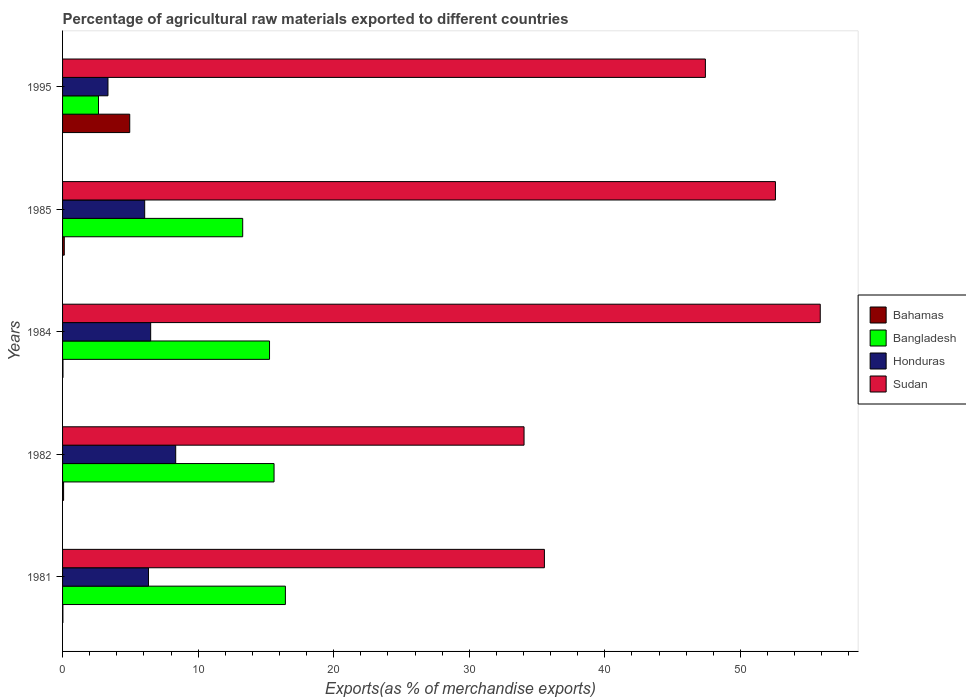How many different coloured bars are there?
Your response must be concise. 4. Are the number of bars on each tick of the Y-axis equal?
Give a very brief answer. Yes. How many bars are there on the 2nd tick from the top?
Keep it short and to the point. 4. In how many cases, is the number of bars for a given year not equal to the number of legend labels?
Keep it short and to the point. 0. What is the percentage of exports to different countries in Sudan in 1981?
Offer a very short reply. 35.54. Across all years, what is the maximum percentage of exports to different countries in Bangladesh?
Your answer should be very brief. 16.44. Across all years, what is the minimum percentage of exports to different countries in Bangladesh?
Your response must be concise. 2.65. In which year was the percentage of exports to different countries in Sudan maximum?
Your answer should be very brief. 1984. What is the total percentage of exports to different countries in Sudan in the graph?
Ensure brevity in your answer.  225.48. What is the difference between the percentage of exports to different countries in Bangladesh in 1981 and that in 1984?
Give a very brief answer. 1.17. What is the difference between the percentage of exports to different countries in Honduras in 1981 and the percentage of exports to different countries in Sudan in 1985?
Make the answer very short. -46.25. What is the average percentage of exports to different countries in Bangladesh per year?
Your response must be concise. 12.65. In the year 1984, what is the difference between the percentage of exports to different countries in Bahamas and percentage of exports to different countries in Bangladesh?
Provide a succinct answer. -15.24. What is the ratio of the percentage of exports to different countries in Bangladesh in 1981 to that in 1984?
Your answer should be compact. 1.08. Is the percentage of exports to different countries in Bangladesh in 1985 less than that in 1995?
Your answer should be very brief. No. Is the difference between the percentage of exports to different countries in Bahamas in 1981 and 1985 greater than the difference between the percentage of exports to different countries in Bangladesh in 1981 and 1985?
Keep it short and to the point. No. What is the difference between the highest and the second highest percentage of exports to different countries in Honduras?
Your answer should be very brief. 1.85. What is the difference between the highest and the lowest percentage of exports to different countries in Bahamas?
Give a very brief answer. 4.93. In how many years, is the percentage of exports to different countries in Honduras greater than the average percentage of exports to different countries in Honduras taken over all years?
Your answer should be very brief. 3. What does the 4th bar from the top in 1985 represents?
Your answer should be very brief. Bahamas. What does the 1st bar from the bottom in 1985 represents?
Give a very brief answer. Bahamas. Is it the case that in every year, the sum of the percentage of exports to different countries in Honduras and percentage of exports to different countries in Sudan is greater than the percentage of exports to different countries in Bangladesh?
Your response must be concise. Yes. Are all the bars in the graph horizontal?
Offer a terse response. Yes. How many years are there in the graph?
Offer a very short reply. 5. What is the difference between two consecutive major ticks on the X-axis?
Keep it short and to the point. 10. What is the title of the graph?
Make the answer very short. Percentage of agricultural raw materials exported to different countries. Does "Fragile and conflict affected situations" appear as one of the legend labels in the graph?
Ensure brevity in your answer.  No. What is the label or title of the X-axis?
Your response must be concise. Exports(as % of merchandise exports). What is the label or title of the Y-axis?
Your response must be concise. Years. What is the Exports(as % of merchandise exports) in Bahamas in 1981?
Your answer should be very brief. 0.02. What is the Exports(as % of merchandise exports) in Bangladesh in 1981?
Offer a terse response. 16.44. What is the Exports(as % of merchandise exports) of Honduras in 1981?
Offer a very short reply. 6.34. What is the Exports(as % of merchandise exports) of Sudan in 1981?
Your answer should be very brief. 35.54. What is the Exports(as % of merchandise exports) of Bahamas in 1982?
Offer a terse response. 0.08. What is the Exports(as % of merchandise exports) in Bangladesh in 1982?
Give a very brief answer. 15.6. What is the Exports(as % of merchandise exports) in Honduras in 1982?
Make the answer very short. 8.35. What is the Exports(as % of merchandise exports) of Sudan in 1982?
Make the answer very short. 34.04. What is the Exports(as % of merchandise exports) in Bahamas in 1984?
Give a very brief answer. 0.03. What is the Exports(as % of merchandise exports) of Bangladesh in 1984?
Offer a very short reply. 15.27. What is the Exports(as % of merchandise exports) of Honduras in 1984?
Make the answer very short. 6.5. What is the Exports(as % of merchandise exports) of Sudan in 1984?
Make the answer very short. 55.89. What is the Exports(as % of merchandise exports) of Bahamas in 1985?
Ensure brevity in your answer.  0.13. What is the Exports(as % of merchandise exports) in Bangladesh in 1985?
Offer a terse response. 13.29. What is the Exports(as % of merchandise exports) of Honduras in 1985?
Ensure brevity in your answer.  6.06. What is the Exports(as % of merchandise exports) in Sudan in 1985?
Make the answer very short. 52.59. What is the Exports(as % of merchandise exports) in Bahamas in 1995?
Your answer should be very brief. 4.95. What is the Exports(as % of merchandise exports) in Bangladesh in 1995?
Keep it short and to the point. 2.65. What is the Exports(as % of merchandise exports) in Honduras in 1995?
Provide a short and direct response. 3.35. What is the Exports(as % of merchandise exports) of Sudan in 1995?
Ensure brevity in your answer.  47.42. Across all years, what is the maximum Exports(as % of merchandise exports) in Bahamas?
Your answer should be very brief. 4.95. Across all years, what is the maximum Exports(as % of merchandise exports) in Bangladesh?
Offer a very short reply. 16.44. Across all years, what is the maximum Exports(as % of merchandise exports) in Honduras?
Provide a short and direct response. 8.35. Across all years, what is the maximum Exports(as % of merchandise exports) of Sudan?
Your answer should be compact. 55.89. Across all years, what is the minimum Exports(as % of merchandise exports) of Bahamas?
Offer a terse response. 0.02. Across all years, what is the minimum Exports(as % of merchandise exports) in Bangladesh?
Keep it short and to the point. 2.65. Across all years, what is the minimum Exports(as % of merchandise exports) of Honduras?
Your answer should be compact. 3.35. Across all years, what is the minimum Exports(as % of merchandise exports) of Sudan?
Provide a succinct answer. 34.04. What is the total Exports(as % of merchandise exports) of Bahamas in the graph?
Your answer should be very brief. 5.21. What is the total Exports(as % of merchandise exports) of Bangladesh in the graph?
Provide a succinct answer. 63.24. What is the total Exports(as % of merchandise exports) in Honduras in the graph?
Keep it short and to the point. 30.59. What is the total Exports(as % of merchandise exports) of Sudan in the graph?
Your response must be concise. 225.48. What is the difference between the Exports(as % of merchandise exports) in Bahamas in 1981 and that in 1982?
Your answer should be very brief. -0.05. What is the difference between the Exports(as % of merchandise exports) in Bangladesh in 1981 and that in 1982?
Your response must be concise. 0.84. What is the difference between the Exports(as % of merchandise exports) of Honduras in 1981 and that in 1982?
Offer a terse response. -2.01. What is the difference between the Exports(as % of merchandise exports) of Sudan in 1981 and that in 1982?
Offer a terse response. 1.5. What is the difference between the Exports(as % of merchandise exports) of Bahamas in 1981 and that in 1984?
Give a very brief answer. -0.01. What is the difference between the Exports(as % of merchandise exports) in Bangladesh in 1981 and that in 1984?
Your answer should be very brief. 1.17. What is the difference between the Exports(as % of merchandise exports) of Honduras in 1981 and that in 1984?
Your response must be concise. -0.16. What is the difference between the Exports(as % of merchandise exports) in Sudan in 1981 and that in 1984?
Your answer should be very brief. -20.35. What is the difference between the Exports(as % of merchandise exports) in Bahamas in 1981 and that in 1985?
Your answer should be compact. -0.1. What is the difference between the Exports(as % of merchandise exports) in Bangladesh in 1981 and that in 1985?
Ensure brevity in your answer.  3.15. What is the difference between the Exports(as % of merchandise exports) in Honduras in 1981 and that in 1985?
Your answer should be compact. 0.28. What is the difference between the Exports(as % of merchandise exports) of Sudan in 1981 and that in 1985?
Your answer should be compact. -17.04. What is the difference between the Exports(as % of merchandise exports) of Bahamas in 1981 and that in 1995?
Keep it short and to the point. -4.93. What is the difference between the Exports(as % of merchandise exports) of Bangladesh in 1981 and that in 1995?
Ensure brevity in your answer.  13.79. What is the difference between the Exports(as % of merchandise exports) of Honduras in 1981 and that in 1995?
Your answer should be compact. 2.99. What is the difference between the Exports(as % of merchandise exports) in Sudan in 1981 and that in 1995?
Ensure brevity in your answer.  -11.88. What is the difference between the Exports(as % of merchandise exports) in Bahamas in 1982 and that in 1984?
Ensure brevity in your answer.  0.05. What is the difference between the Exports(as % of merchandise exports) in Bangladesh in 1982 and that in 1984?
Your answer should be very brief. 0.33. What is the difference between the Exports(as % of merchandise exports) in Honduras in 1982 and that in 1984?
Make the answer very short. 1.85. What is the difference between the Exports(as % of merchandise exports) in Sudan in 1982 and that in 1984?
Give a very brief answer. -21.85. What is the difference between the Exports(as % of merchandise exports) of Bahamas in 1982 and that in 1985?
Keep it short and to the point. -0.05. What is the difference between the Exports(as % of merchandise exports) of Bangladesh in 1982 and that in 1985?
Offer a very short reply. 2.31. What is the difference between the Exports(as % of merchandise exports) of Honduras in 1982 and that in 1985?
Make the answer very short. 2.29. What is the difference between the Exports(as % of merchandise exports) in Sudan in 1982 and that in 1985?
Make the answer very short. -18.54. What is the difference between the Exports(as % of merchandise exports) of Bahamas in 1982 and that in 1995?
Give a very brief answer. -4.88. What is the difference between the Exports(as % of merchandise exports) in Bangladesh in 1982 and that in 1995?
Keep it short and to the point. 12.95. What is the difference between the Exports(as % of merchandise exports) in Honduras in 1982 and that in 1995?
Offer a terse response. 5. What is the difference between the Exports(as % of merchandise exports) in Sudan in 1982 and that in 1995?
Ensure brevity in your answer.  -13.38. What is the difference between the Exports(as % of merchandise exports) of Bahamas in 1984 and that in 1985?
Offer a terse response. -0.1. What is the difference between the Exports(as % of merchandise exports) of Bangladesh in 1984 and that in 1985?
Provide a short and direct response. 1.98. What is the difference between the Exports(as % of merchandise exports) in Honduras in 1984 and that in 1985?
Your answer should be very brief. 0.44. What is the difference between the Exports(as % of merchandise exports) of Sudan in 1984 and that in 1985?
Make the answer very short. 3.31. What is the difference between the Exports(as % of merchandise exports) of Bahamas in 1984 and that in 1995?
Give a very brief answer. -4.92. What is the difference between the Exports(as % of merchandise exports) of Bangladesh in 1984 and that in 1995?
Give a very brief answer. 12.62. What is the difference between the Exports(as % of merchandise exports) of Honduras in 1984 and that in 1995?
Provide a short and direct response. 3.15. What is the difference between the Exports(as % of merchandise exports) of Sudan in 1984 and that in 1995?
Give a very brief answer. 8.47. What is the difference between the Exports(as % of merchandise exports) in Bahamas in 1985 and that in 1995?
Your answer should be very brief. -4.83. What is the difference between the Exports(as % of merchandise exports) in Bangladesh in 1985 and that in 1995?
Your answer should be compact. 10.64. What is the difference between the Exports(as % of merchandise exports) of Honduras in 1985 and that in 1995?
Keep it short and to the point. 2.71. What is the difference between the Exports(as % of merchandise exports) of Sudan in 1985 and that in 1995?
Keep it short and to the point. 5.17. What is the difference between the Exports(as % of merchandise exports) of Bahamas in 1981 and the Exports(as % of merchandise exports) of Bangladesh in 1982?
Your answer should be compact. -15.58. What is the difference between the Exports(as % of merchandise exports) in Bahamas in 1981 and the Exports(as % of merchandise exports) in Honduras in 1982?
Offer a terse response. -8.32. What is the difference between the Exports(as % of merchandise exports) in Bahamas in 1981 and the Exports(as % of merchandise exports) in Sudan in 1982?
Offer a very short reply. -34.02. What is the difference between the Exports(as % of merchandise exports) of Bangladesh in 1981 and the Exports(as % of merchandise exports) of Honduras in 1982?
Provide a short and direct response. 8.09. What is the difference between the Exports(as % of merchandise exports) of Bangladesh in 1981 and the Exports(as % of merchandise exports) of Sudan in 1982?
Make the answer very short. -17.61. What is the difference between the Exports(as % of merchandise exports) in Honduras in 1981 and the Exports(as % of merchandise exports) in Sudan in 1982?
Provide a succinct answer. -27.7. What is the difference between the Exports(as % of merchandise exports) of Bahamas in 1981 and the Exports(as % of merchandise exports) of Bangladesh in 1984?
Offer a terse response. -15.24. What is the difference between the Exports(as % of merchandise exports) of Bahamas in 1981 and the Exports(as % of merchandise exports) of Honduras in 1984?
Your response must be concise. -6.48. What is the difference between the Exports(as % of merchandise exports) in Bahamas in 1981 and the Exports(as % of merchandise exports) in Sudan in 1984?
Keep it short and to the point. -55.87. What is the difference between the Exports(as % of merchandise exports) in Bangladesh in 1981 and the Exports(as % of merchandise exports) in Honduras in 1984?
Your answer should be very brief. 9.94. What is the difference between the Exports(as % of merchandise exports) in Bangladesh in 1981 and the Exports(as % of merchandise exports) in Sudan in 1984?
Give a very brief answer. -39.45. What is the difference between the Exports(as % of merchandise exports) in Honduras in 1981 and the Exports(as % of merchandise exports) in Sudan in 1984?
Make the answer very short. -49.55. What is the difference between the Exports(as % of merchandise exports) in Bahamas in 1981 and the Exports(as % of merchandise exports) in Bangladesh in 1985?
Give a very brief answer. -13.26. What is the difference between the Exports(as % of merchandise exports) in Bahamas in 1981 and the Exports(as % of merchandise exports) in Honduras in 1985?
Provide a short and direct response. -6.03. What is the difference between the Exports(as % of merchandise exports) in Bahamas in 1981 and the Exports(as % of merchandise exports) in Sudan in 1985?
Your answer should be very brief. -52.56. What is the difference between the Exports(as % of merchandise exports) in Bangladesh in 1981 and the Exports(as % of merchandise exports) in Honduras in 1985?
Make the answer very short. 10.38. What is the difference between the Exports(as % of merchandise exports) of Bangladesh in 1981 and the Exports(as % of merchandise exports) of Sudan in 1985?
Give a very brief answer. -36.15. What is the difference between the Exports(as % of merchandise exports) in Honduras in 1981 and the Exports(as % of merchandise exports) in Sudan in 1985?
Your answer should be very brief. -46.25. What is the difference between the Exports(as % of merchandise exports) of Bahamas in 1981 and the Exports(as % of merchandise exports) of Bangladesh in 1995?
Your answer should be compact. -2.63. What is the difference between the Exports(as % of merchandise exports) of Bahamas in 1981 and the Exports(as % of merchandise exports) of Honduras in 1995?
Offer a very short reply. -3.32. What is the difference between the Exports(as % of merchandise exports) in Bahamas in 1981 and the Exports(as % of merchandise exports) in Sudan in 1995?
Offer a terse response. -47.39. What is the difference between the Exports(as % of merchandise exports) of Bangladesh in 1981 and the Exports(as % of merchandise exports) of Honduras in 1995?
Offer a terse response. 13.09. What is the difference between the Exports(as % of merchandise exports) in Bangladesh in 1981 and the Exports(as % of merchandise exports) in Sudan in 1995?
Give a very brief answer. -30.98. What is the difference between the Exports(as % of merchandise exports) of Honduras in 1981 and the Exports(as % of merchandise exports) of Sudan in 1995?
Offer a terse response. -41.08. What is the difference between the Exports(as % of merchandise exports) of Bahamas in 1982 and the Exports(as % of merchandise exports) of Bangladesh in 1984?
Keep it short and to the point. -15.19. What is the difference between the Exports(as % of merchandise exports) in Bahamas in 1982 and the Exports(as % of merchandise exports) in Honduras in 1984?
Offer a terse response. -6.42. What is the difference between the Exports(as % of merchandise exports) in Bahamas in 1982 and the Exports(as % of merchandise exports) in Sudan in 1984?
Offer a terse response. -55.81. What is the difference between the Exports(as % of merchandise exports) of Bangladesh in 1982 and the Exports(as % of merchandise exports) of Honduras in 1984?
Offer a very short reply. 9.1. What is the difference between the Exports(as % of merchandise exports) of Bangladesh in 1982 and the Exports(as % of merchandise exports) of Sudan in 1984?
Offer a terse response. -40.29. What is the difference between the Exports(as % of merchandise exports) in Honduras in 1982 and the Exports(as % of merchandise exports) in Sudan in 1984?
Offer a very short reply. -47.54. What is the difference between the Exports(as % of merchandise exports) of Bahamas in 1982 and the Exports(as % of merchandise exports) of Bangladesh in 1985?
Offer a very short reply. -13.21. What is the difference between the Exports(as % of merchandise exports) of Bahamas in 1982 and the Exports(as % of merchandise exports) of Honduras in 1985?
Your response must be concise. -5.98. What is the difference between the Exports(as % of merchandise exports) of Bahamas in 1982 and the Exports(as % of merchandise exports) of Sudan in 1985?
Provide a short and direct response. -52.51. What is the difference between the Exports(as % of merchandise exports) in Bangladesh in 1982 and the Exports(as % of merchandise exports) in Honduras in 1985?
Provide a short and direct response. 9.54. What is the difference between the Exports(as % of merchandise exports) in Bangladesh in 1982 and the Exports(as % of merchandise exports) in Sudan in 1985?
Provide a succinct answer. -36.99. What is the difference between the Exports(as % of merchandise exports) of Honduras in 1982 and the Exports(as % of merchandise exports) of Sudan in 1985?
Make the answer very short. -44.24. What is the difference between the Exports(as % of merchandise exports) of Bahamas in 1982 and the Exports(as % of merchandise exports) of Bangladesh in 1995?
Keep it short and to the point. -2.57. What is the difference between the Exports(as % of merchandise exports) of Bahamas in 1982 and the Exports(as % of merchandise exports) of Honduras in 1995?
Keep it short and to the point. -3.27. What is the difference between the Exports(as % of merchandise exports) in Bahamas in 1982 and the Exports(as % of merchandise exports) in Sudan in 1995?
Ensure brevity in your answer.  -47.34. What is the difference between the Exports(as % of merchandise exports) of Bangladesh in 1982 and the Exports(as % of merchandise exports) of Honduras in 1995?
Your response must be concise. 12.25. What is the difference between the Exports(as % of merchandise exports) in Bangladesh in 1982 and the Exports(as % of merchandise exports) in Sudan in 1995?
Offer a terse response. -31.82. What is the difference between the Exports(as % of merchandise exports) in Honduras in 1982 and the Exports(as % of merchandise exports) in Sudan in 1995?
Provide a short and direct response. -39.07. What is the difference between the Exports(as % of merchandise exports) in Bahamas in 1984 and the Exports(as % of merchandise exports) in Bangladesh in 1985?
Provide a succinct answer. -13.26. What is the difference between the Exports(as % of merchandise exports) in Bahamas in 1984 and the Exports(as % of merchandise exports) in Honduras in 1985?
Your answer should be very brief. -6.03. What is the difference between the Exports(as % of merchandise exports) of Bahamas in 1984 and the Exports(as % of merchandise exports) of Sudan in 1985?
Your answer should be compact. -52.55. What is the difference between the Exports(as % of merchandise exports) in Bangladesh in 1984 and the Exports(as % of merchandise exports) in Honduras in 1985?
Provide a succinct answer. 9.21. What is the difference between the Exports(as % of merchandise exports) of Bangladesh in 1984 and the Exports(as % of merchandise exports) of Sudan in 1985?
Keep it short and to the point. -37.32. What is the difference between the Exports(as % of merchandise exports) in Honduras in 1984 and the Exports(as % of merchandise exports) in Sudan in 1985?
Your response must be concise. -46.09. What is the difference between the Exports(as % of merchandise exports) in Bahamas in 1984 and the Exports(as % of merchandise exports) in Bangladesh in 1995?
Offer a terse response. -2.62. What is the difference between the Exports(as % of merchandise exports) in Bahamas in 1984 and the Exports(as % of merchandise exports) in Honduras in 1995?
Give a very brief answer. -3.32. What is the difference between the Exports(as % of merchandise exports) in Bahamas in 1984 and the Exports(as % of merchandise exports) in Sudan in 1995?
Keep it short and to the point. -47.39. What is the difference between the Exports(as % of merchandise exports) of Bangladesh in 1984 and the Exports(as % of merchandise exports) of Honduras in 1995?
Give a very brief answer. 11.92. What is the difference between the Exports(as % of merchandise exports) of Bangladesh in 1984 and the Exports(as % of merchandise exports) of Sudan in 1995?
Provide a short and direct response. -32.15. What is the difference between the Exports(as % of merchandise exports) of Honduras in 1984 and the Exports(as % of merchandise exports) of Sudan in 1995?
Give a very brief answer. -40.92. What is the difference between the Exports(as % of merchandise exports) in Bahamas in 1985 and the Exports(as % of merchandise exports) in Bangladesh in 1995?
Give a very brief answer. -2.52. What is the difference between the Exports(as % of merchandise exports) in Bahamas in 1985 and the Exports(as % of merchandise exports) in Honduras in 1995?
Your answer should be compact. -3.22. What is the difference between the Exports(as % of merchandise exports) in Bahamas in 1985 and the Exports(as % of merchandise exports) in Sudan in 1995?
Ensure brevity in your answer.  -47.29. What is the difference between the Exports(as % of merchandise exports) in Bangladesh in 1985 and the Exports(as % of merchandise exports) in Honduras in 1995?
Provide a succinct answer. 9.94. What is the difference between the Exports(as % of merchandise exports) in Bangladesh in 1985 and the Exports(as % of merchandise exports) in Sudan in 1995?
Provide a succinct answer. -34.13. What is the difference between the Exports(as % of merchandise exports) in Honduras in 1985 and the Exports(as % of merchandise exports) in Sudan in 1995?
Provide a succinct answer. -41.36. What is the average Exports(as % of merchandise exports) in Bahamas per year?
Make the answer very short. 1.04. What is the average Exports(as % of merchandise exports) in Bangladesh per year?
Provide a succinct answer. 12.65. What is the average Exports(as % of merchandise exports) in Honduras per year?
Give a very brief answer. 6.12. What is the average Exports(as % of merchandise exports) of Sudan per year?
Offer a terse response. 45.1. In the year 1981, what is the difference between the Exports(as % of merchandise exports) of Bahamas and Exports(as % of merchandise exports) of Bangladesh?
Your answer should be compact. -16.41. In the year 1981, what is the difference between the Exports(as % of merchandise exports) in Bahamas and Exports(as % of merchandise exports) in Honduras?
Provide a succinct answer. -6.31. In the year 1981, what is the difference between the Exports(as % of merchandise exports) of Bahamas and Exports(as % of merchandise exports) of Sudan?
Make the answer very short. -35.52. In the year 1981, what is the difference between the Exports(as % of merchandise exports) in Bangladesh and Exports(as % of merchandise exports) in Honduras?
Offer a terse response. 10.1. In the year 1981, what is the difference between the Exports(as % of merchandise exports) in Bangladesh and Exports(as % of merchandise exports) in Sudan?
Offer a terse response. -19.11. In the year 1981, what is the difference between the Exports(as % of merchandise exports) of Honduras and Exports(as % of merchandise exports) of Sudan?
Provide a short and direct response. -29.2. In the year 1982, what is the difference between the Exports(as % of merchandise exports) in Bahamas and Exports(as % of merchandise exports) in Bangladesh?
Offer a very short reply. -15.52. In the year 1982, what is the difference between the Exports(as % of merchandise exports) in Bahamas and Exports(as % of merchandise exports) in Honduras?
Give a very brief answer. -8.27. In the year 1982, what is the difference between the Exports(as % of merchandise exports) in Bahamas and Exports(as % of merchandise exports) in Sudan?
Provide a succinct answer. -33.97. In the year 1982, what is the difference between the Exports(as % of merchandise exports) of Bangladesh and Exports(as % of merchandise exports) of Honduras?
Offer a terse response. 7.25. In the year 1982, what is the difference between the Exports(as % of merchandise exports) in Bangladesh and Exports(as % of merchandise exports) in Sudan?
Provide a succinct answer. -18.44. In the year 1982, what is the difference between the Exports(as % of merchandise exports) in Honduras and Exports(as % of merchandise exports) in Sudan?
Keep it short and to the point. -25.7. In the year 1984, what is the difference between the Exports(as % of merchandise exports) of Bahamas and Exports(as % of merchandise exports) of Bangladesh?
Make the answer very short. -15.24. In the year 1984, what is the difference between the Exports(as % of merchandise exports) in Bahamas and Exports(as % of merchandise exports) in Honduras?
Your answer should be very brief. -6.47. In the year 1984, what is the difference between the Exports(as % of merchandise exports) of Bahamas and Exports(as % of merchandise exports) of Sudan?
Your answer should be very brief. -55.86. In the year 1984, what is the difference between the Exports(as % of merchandise exports) in Bangladesh and Exports(as % of merchandise exports) in Honduras?
Provide a short and direct response. 8.77. In the year 1984, what is the difference between the Exports(as % of merchandise exports) of Bangladesh and Exports(as % of merchandise exports) of Sudan?
Provide a short and direct response. -40.62. In the year 1984, what is the difference between the Exports(as % of merchandise exports) in Honduras and Exports(as % of merchandise exports) in Sudan?
Make the answer very short. -49.39. In the year 1985, what is the difference between the Exports(as % of merchandise exports) of Bahamas and Exports(as % of merchandise exports) of Bangladesh?
Provide a short and direct response. -13.16. In the year 1985, what is the difference between the Exports(as % of merchandise exports) of Bahamas and Exports(as % of merchandise exports) of Honduras?
Ensure brevity in your answer.  -5.93. In the year 1985, what is the difference between the Exports(as % of merchandise exports) in Bahamas and Exports(as % of merchandise exports) in Sudan?
Provide a short and direct response. -52.46. In the year 1985, what is the difference between the Exports(as % of merchandise exports) in Bangladesh and Exports(as % of merchandise exports) in Honduras?
Ensure brevity in your answer.  7.23. In the year 1985, what is the difference between the Exports(as % of merchandise exports) of Bangladesh and Exports(as % of merchandise exports) of Sudan?
Make the answer very short. -39.3. In the year 1985, what is the difference between the Exports(as % of merchandise exports) of Honduras and Exports(as % of merchandise exports) of Sudan?
Ensure brevity in your answer.  -46.53. In the year 1995, what is the difference between the Exports(as % of merchandise exports) in Bahamas and Exports(as % of merchandise exports) in Bangladesh?
Offer a terse response. 2.3. In the year 1995, what is the difference between the Exports(as % of merchandise exports) in Bahamas and Exports(as % of merchandise exports) in Honduras?
Keep it short and to the point. 1.61. In the year 1995, what is the difference between the Exports(as % of merchandise exports) in Bahamas and Exports(as % of merchandise exports) in Sudan?
Offer a very short reply. -42.46. In the year 1995, what is the difference between the Exports(as % of merchandise exports) of Bangladesh and Exports(as % of merchandise exports) of Honduras?
Keep it short and to the point. -0.7. In the year 1995, what is the difference between the Exports(as % of merchandise exports) in Bangladesh and Exports(as % of merchandise exports) in Sudan?
Offer a terse response. -44.77. In the year 1995, what is the difference between the Exports(as % of merchandise exports) of Honduras and Exports(as % of merchandise exports) of Sudan?
Offer a terse response. -44.07. What is the ratio of the Exports(as % of merchandise exports) of Bahamas in 1981 to that in 1982?
Your response must be concise. 0.31. What is the ratio of the Exports(as % of merchandise exports) in Bangladesh in 1981 to that in 1982?
Offer a very short reply. 1.05. What is the ratio of the Exports(as % of merchandise exports) in Honduras in 1981 to that in 1982?
Make the answer very short. 0.76. What is the ratio of the Exports(as % of merchandise exports) of Sudan in 1981 to that in 1982?
Offer a very short reply. 1.04. What is the ratio of the Exports(as % of merchandise exports) in Bahamas in 1981 to that in 1984?
Your response must be concise. 0.78. What is the ratio of the Exports(as % of merchandise exports) in Bangladesh in 1981 to that in 1984?
Your response must be concise. 1.08. What is the ratio of the Exports(as % of merchandise exports) in Honduras in 1981 to that in 1984?
Your answer should be very brief. 0.98. What is the ratio of the Exports(as % of merchandise exports) in Sudan in 1981 to that in 1984?
Ensure brevity in your answer.  0.64. What is the ratio of the Exports(as % of merchandise exports) of Bahamas in 1981 to that in 1985?
Your answer should be compact. 0.19. What is the ratio of the Exports(as % of merchandise exports) of Bangladesh in 1981 to that in 1985?
Ensure brevity in your answer.  1.24. What is the ratio of the Exports(as % of merchandise exports) of Honduras in 1981 to that in 1985?
Provide a short and direct response. 1.05. What is the ratio of the Exports(as % of merchandise exports) in Sudan in 1981 to that in 1985?
Ensure brevity in your answer.  0.68. What is the ratio of the Exports(as % of merchandise exports) in Bahamas in 1981 to that in 1995?
Ensure brevity in your answer.  0. What is the ratio of the Exports(as % of merchandise exports) in Bangladesh in 1981 to that in 1995?
Ensure brevity in your answer.  6.2. What is the ratio of the Exports(as % of merchandise exports) of Honduras in 1981 to that in 1995?
Make the answer very short. 1.89. What is the ratio of the Exports(as % of merchandise exports) of Sudan in 1981 to that in 1995?
Offer a terse response. 0.75. What is the ratio of the Exports(as % of merchandise exports) of Bahamas in 1982 to that in 1984?
Provide a succinct answer. 2.49. What is the ratio of the Exports(as % of merchandise exports) in Bangladesh in 1982 to that in 1984?
Offer a terse response. 1.02. What is the ratio of the Exports(as % of merchandise exports) in Honduras in 1982 to that in 1984?
Your answer should be very brief. 1.28. What is the ratio of the Exports(as % of merchandise exports) in Sudan in 1982 to that in 1984?
Your answer should be very brief. 0.61. What is the ratio of the Exports(as % of merchandise exports) of Bahamas in 1982 to that in 1985?
Your response must be concise. 0.6. What is the ratio of the Exports(as % of merchandise exports) of Bangladesh in 1982 to that in 1985?
Offer a very short reply. 1.17. What is the ratio of the Exports(as % of merchandise exports) of Honduras in 1982 to that in 1985?
Give a very brief answer. 1.38. What is the ratio of the Exports(as % of merchandise exports) of Sudan in 1982 to that in 1985?
Provide a short and direct response. 0.65. What is the ratio of the Exports(as % of merchandise exports) of Bahamas in 1982 to that in 1995?
Your response must be concise. 0.02. What is the ratio of the Exports(as % of merchandise exports) in Bangladesh in 1982 to that in 1995?
Keep it short and to the point. 5.88. What is the ratio of the Exports(as % of merchandise exports) in Honduras in 1982 to that in 1995?
Your answer should be very brief. 2.49. What is the ratio of the Exports(as % of merchandise exports) of Sudan in 1982 to that in 1995?
Ensure brevity in your answer.  0.72. What is the ratio of the Exports(as % of merchandise exports) in Bahamas in 1984 to that in 1985?
Your answer should be compact. 0.24. What is the ratio of the Exports(as % of merchandise exports) in Bangladesh in 1984 to that in 1985?
Your answer should be compact. 1.15. What is the ratio of the Exports(as % of merchandise exports) of Honduras in 1984 to that in 1985?
Offer a very short reply. 1.07. What is the ratio of the Exports(as % of merchandise exports) of Sudan in 1984 to that in 1985?
Keep it short and to the point. 1.06. What is the ratio of the Exports(as % of merchandise exports) in Bahamas in 1984 to that in 1995?
Your answer should be compact. 0.01. What is the ratio of the Exports(as % of merchandise exports) in Bangladesh in 1984 to that in 1995?
Ensure brevity in your answer.  5.76. What is the ratio of the Exports(as % of merchandise exports) in Honduras in 1984 to that in 1995?
Your answer should be very brief. 1.94. What is the ratio of the Exports(as % of merchandise exports) in Sudan in 1984 to that in 1995?
Your response must be concise. 1.18. What is the ratio of the Exports(as % of merchandise exports) of Bahamas in 1985 to that in 1995?
Your answer should be very brief. 0.03. What is the ratio of the Exports(as % of merchandise exports) of Bangladesh in 1985 to that in 1995?
Offer a very short reply. 5.01. What is the ratio of the Exports(as % of merchandise exports) of Honduras in 1985 to that in 1995?
Ensure brevity in your answer.  1.81. What is the ratio of the Exports(as % of merchandise exports) of Sudan in 1985 to that in 1995?
Offer a terse response. 1.11. What is the difference between the highest and the second highest Exports(as % of merchandise exports) in Bahamas?
Ensure brevity in your answer.  4.83. What is the difference between the highest and the second highest Exports(as % of merchandise exports) of Bangladesh?
Your answer should be compact. 0.84. What is the difference between the highest and the second highest Exports(as % of merchandise exports) in Honduras?
Keep it short and to the point. 1.85. What is the difference between the highest and the second highest Exports(as % of merchandise exports) of Sudan?
Give a very brief answer. 3.31. What is the difference between the highest and the lowest Exports(as % of merchandise exports) in Bahamas?
Offer a terse response. 4.93. What is the difference between the highest and the lowest Exports(as % of merchandise exports) in Bangladesh?
Your answer should be very brief. 13.79. What is the difference between the highest and the lowest Exports(as % of merchandise exports) of Honduras?
Your answer should be compact. 5. What is the difference between the highest and the lowest Exports(as % of merchandise exports) of Sudan?
Your response must be concise. 21.85. 